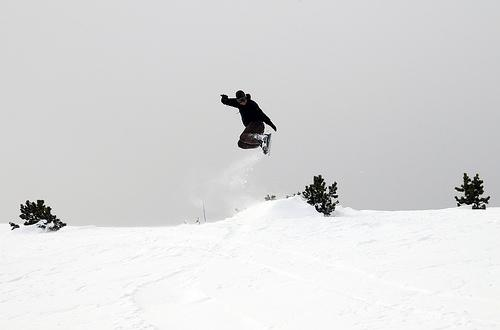List three objects or actions that can be observed in the image. Snowboarder performing a trick, white snow on the ground, and green trees in the background. What is the weather like in the image, and how can you tell? The weather appears to be cold and partly cloudy, indicated by the presence of snow on the ground and the visible clouds in the sky. Are there any notable features or objects in the sky in the image? Please describe them. The sky in the image is partly cloudy with white clouds, providing a bright contrasting background to the bold maneuver performed by the snowboarder in the foreground. Write a short sentence to describe the most visually striking aspect of the image. The dramatic sight of the snowboarder suspended in mid-air, defying gravity as they perform a jaw-dropping trick, draws the eye and captivates the viewer. Describe the position and action of the person in the image as if you are giving a play-by-play commentary. The snowboarder, dressed in all black, is airborne and skillfully bending their knees as they glide through the air, displaying an impressive trick against the crisp white snow and clear sky. Imagine you are advertising this scene as a vacation resort. Write a short advertisement to attract tourists to come and experience it. Discover the thrill of snowboarding amidst the picturesque snowy landscape! Glide through fresh powder snow, surrounded by magnificent green trees, and master daring tricks against the backdrop of a breathtaking sky. Book your adventure today! What is the dominant color in the clothing of the person in the image? The dominant color in the person's clothing is black. What are the different objects interacting with the snow in the image? The snowboarder, their snowboard, and the green trees in the background are interacting with the snow in the image. Imagine you were giving a visual tour to a blind person. How would you describe the person's performance in the image? Picture a snowboarder dressed in black, soaring through the air with bent knees and a focused expression, surrounded by a serene landscape of snow-covered ground and lofty green trees. Choose the best grounding expression to identify the person in the image. The snowboarder wearing all black and catching air near a snow-covered hill. 